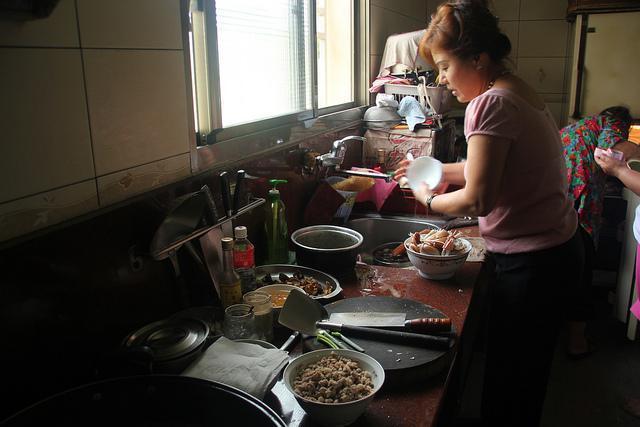How many bowls are there?
Give a very brief answer. 3. How many people are visible?
Give a very brief answer. 2. How many red frisbees can you see?
Give a very brief answer. 0. 